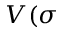Convert formula to latex. <formula><loc_0><loc_0><loc_500><loc_500>V ( \sigma</formula> 